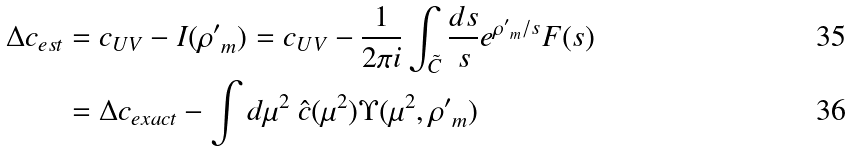Convert formula to latex. <formula><loc_0><loc_0><loc_500><loc_500>\Delta c _ { e s t } = \ & c _ { U V } - I ( { \rho ^ { \prime } } _ { m } ) = c _ { U V } - \frac { 1 } { 2 \pi i } \int _ { \tilde { C } } \frac { d s } { s } e ^ { { \rho ^ { \prime } } _ { m } / s } F ( s ) \\ = \ & \Delta c _ { e x a c t } - \int d \mu ^ { 2 } \ \hat { c } ( \mu ^ { 2 } ) \Upsilon ( \mu ^ { 2 } , { \rho ^ { \prime } } _ { m } )</formula> 